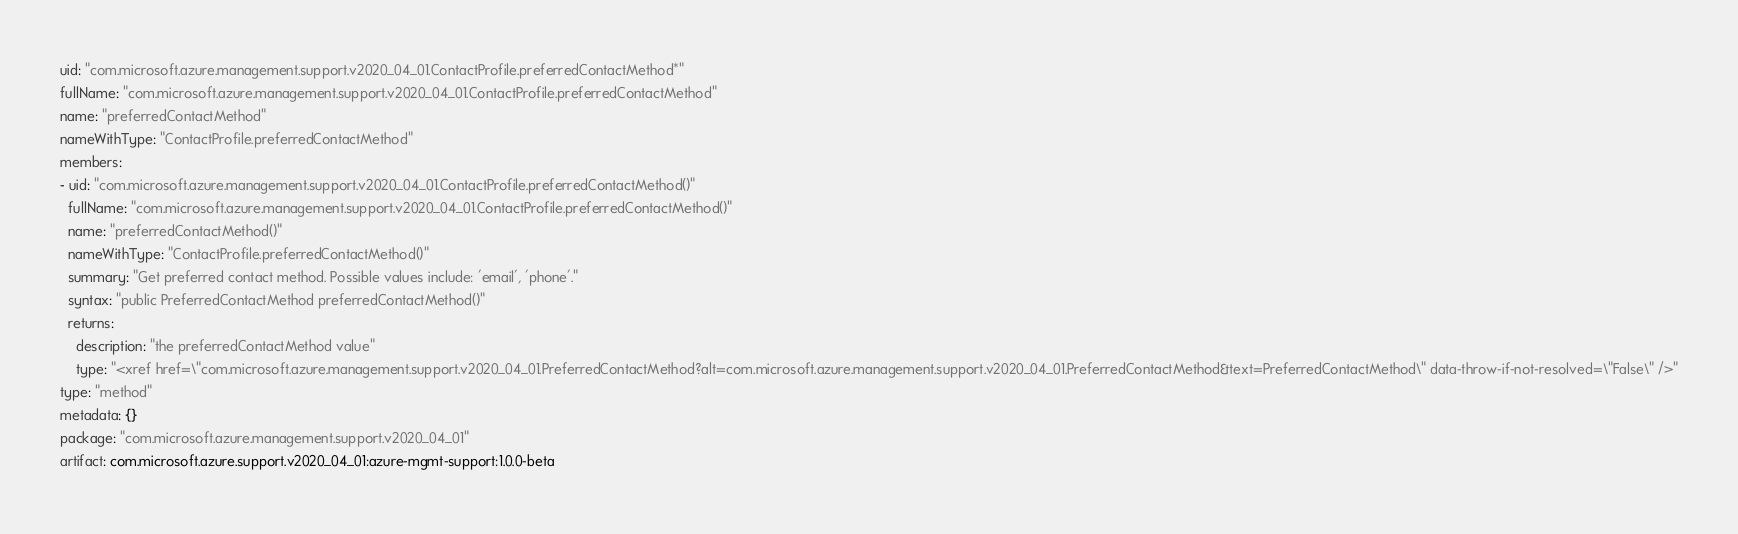<code> <loc_0><loc_0><loc_500><loc_500><_YAML_>uid: "com.microsoft.azure.management.support.v2020_04_01.ContactProfile.preferredContactMethod*"
fullName: "com.microsoft.azure.management.support.v2020_04_01.ContactProfile.preferredContactMethod"
name: "preferredContactMethod"
nameWithType: "ContactProfile.preferredContactMethod"
members:
- uid: "com.microsoft.azure.management.support.v2020_04_01.ContactProfile.preferredContactMethod()"
  fullName: "com.microsoft.azure.management.support.v2020_04_01.ContactProfile.preferredContactMethod()"
  name: "preferredContactMethod()"
  nameWithType: "ContactProfile.preferredContactMethod()"
  summary: "Get preferred contact method. Possible values include: 'email', 'phone'."
  syntax: "public PreferredContactMethod preferredContactMethod()"
  returns:
    description: "the preferredContactMethod value"
    type: "<xref href=\"com.microsoft.azure.management.support.v2020_04_01.PreferredContactMethod?alt=com.microsoft.azure.management.support.v2020_04_01.PreferredContactMethod&text=PreferredContactMethod\" data-throw-if-not-resolved=\"False\" />"
type: "method"
metadata: {}
package: "com.microsoft.azure.management.support.v2020_04_01"
artifact: com.microsoft.azure.support.v2020_04_01:azure-mgmt-support:1.0.0-beta
</code> 